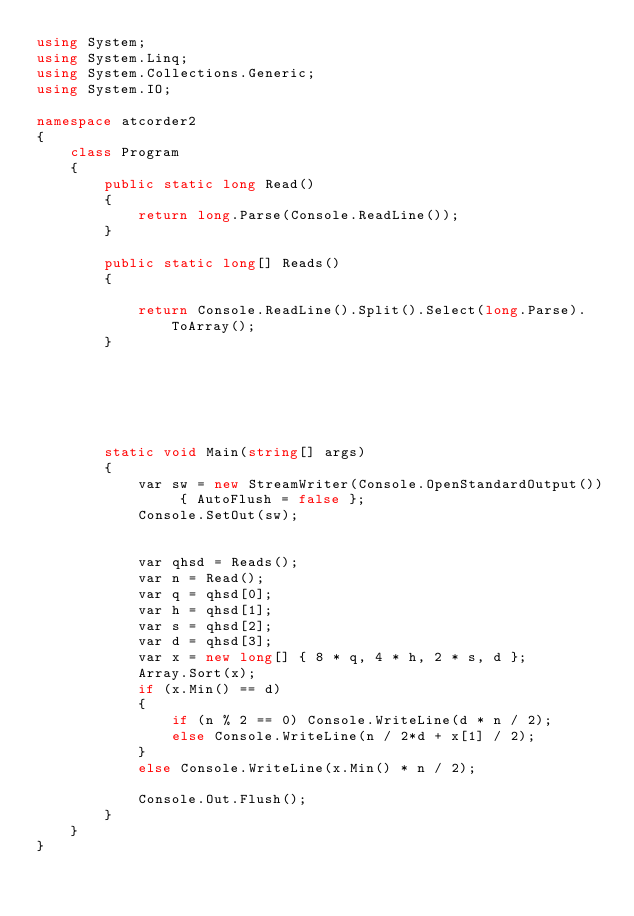<code> <loc_0><loc_0><loc_500><loc_500><_C#_>using System;
using System.Linq;
using System.Collections.Generic;
using System.IO;

namespace atcorder2
{
    class Program
    {
        public static long Read()
        {
            return long.Parse(Console.ReadLine());
        }

        public static long[] Reads()
        {

            return Console.ReadLine().Split().Select(long.Parse).ToArray();
        }






        static void Main(string[] args)
        {
            var sw = new StreamWriter(Console.OpenStandardOutput()) { AutoFlush = false };
            Console.SetOut(sw);


            var qhsd = Reads();
            var n = Read();
            var q = qhsd[0];
            var h = qhsd[1];
            var s = qhsd[2];
            var d = qhsd[3];
            var x = new long[] { 8 * q, 4 * h, 2 * s, d };
            Array.Sort(x);
            if (x.Min() == d)
            {
                if (n % 2 == 0) Console.WriteLine(d * n / 2);
                else Console.WriteLine(n / 2*d + x[1] / 2);
            }
            else Console.WriteLine(x.Min() * n / 2);

            Console.Out.Flush();
        }
    }
}


</code> 